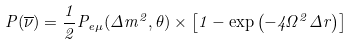<formula> <loc_0><loc_0><loc_500><loc_500>P ( \overline { \nu } ) = \frac { 1 } { 2 } P _ { e \mu } ( \Delta m ^ { 2 } , \theta ) \times \left [ 1 - \exp \left ( - 4 \Omega ^ { 2 } \Delta r \right ) \right ]</formula> 